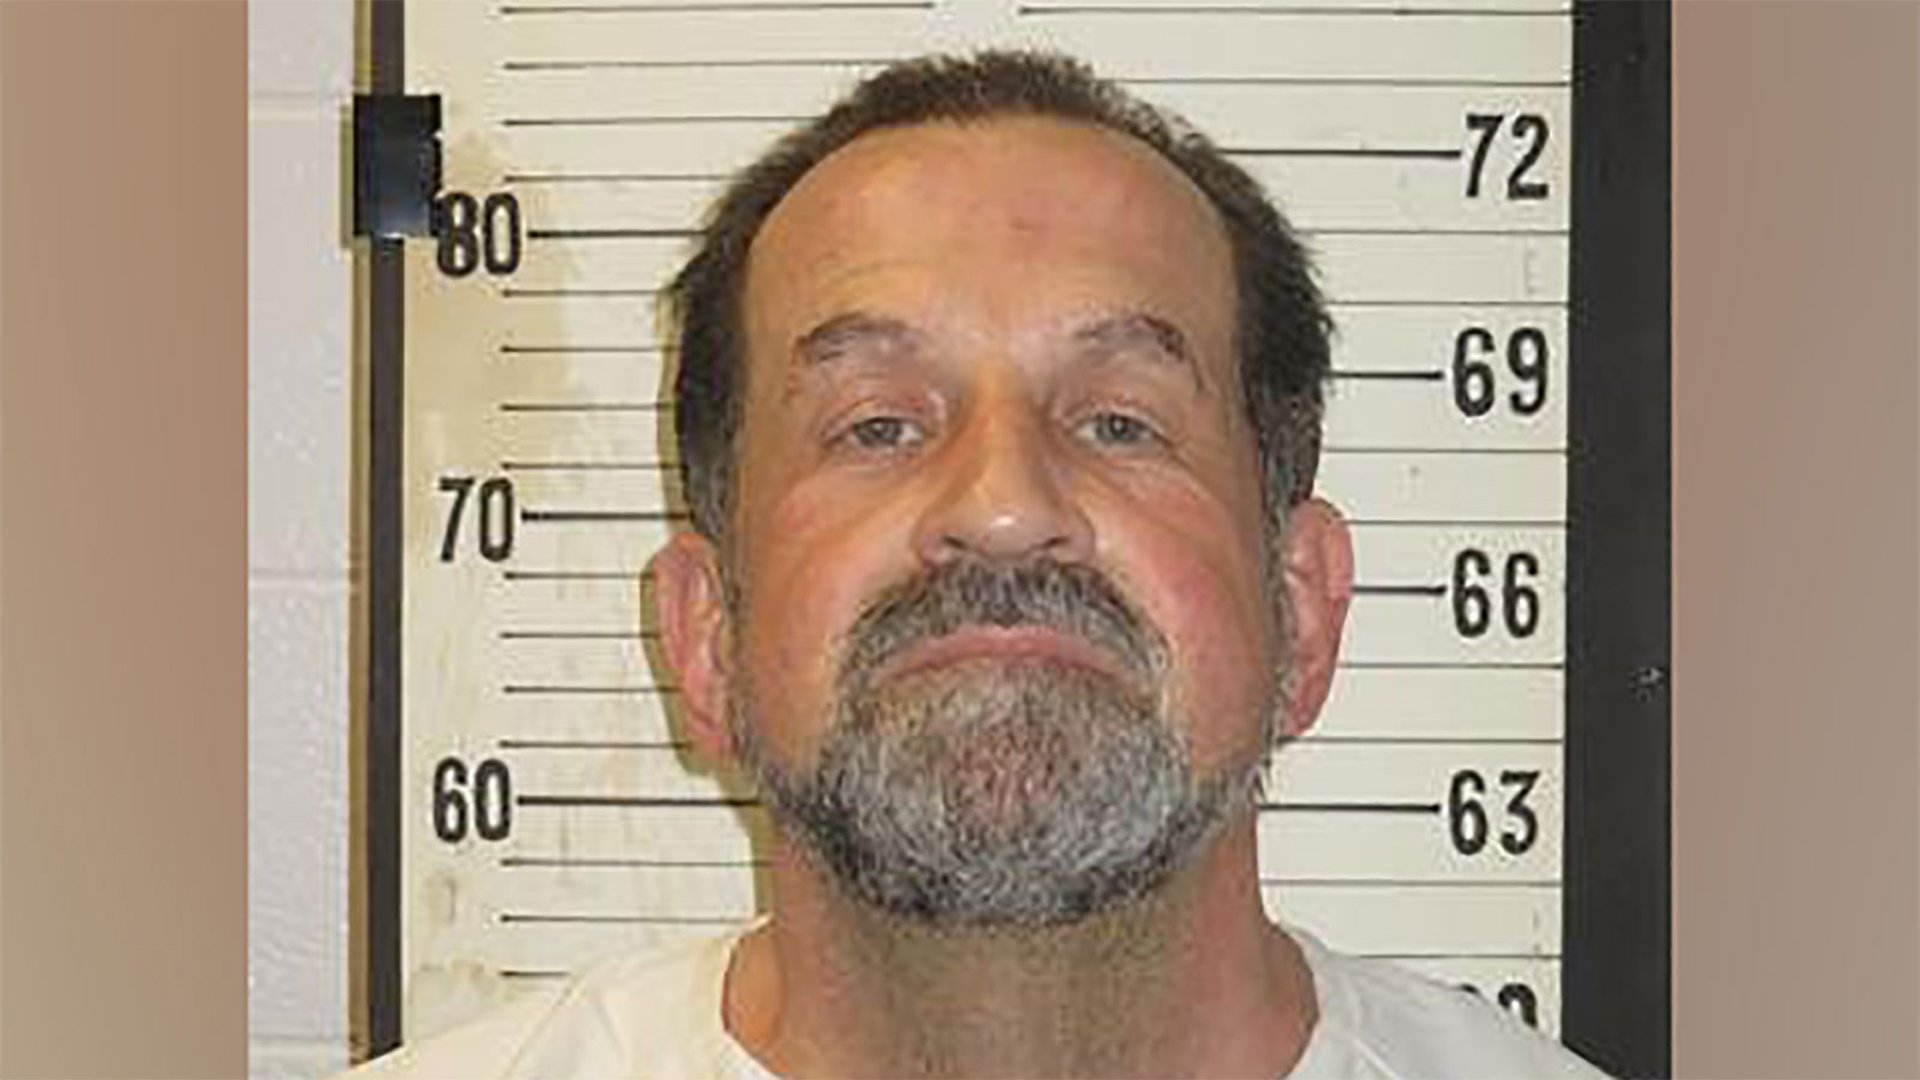Considering the visible height chart in the background, what can we infer about the man's height in centimeters? Based on the height chart behind the man, his height seems to be just below the 69-inch mark. Since each inch is equal to 2.54 centimeters, we can convert his height into centimeters. If he stands at about 68.5 inches, we perform the conversion by multiplying 68.5 by 2.54, giving us approximately 173.99 centimeters. Therefore, we can infer that the man's height is roughly 174 centimeters. 